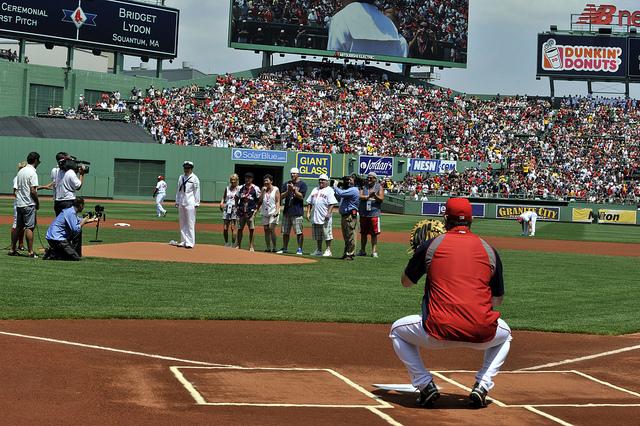What game are they playing?
Write a very short answer. Baseball. What do you call the man behind the catcher?
Be succinct. Umpire. Are there any empty seats?
Answer briefly. No. What company is advertised able Dunkin donuts?
Be succinct. New balance. Is the game starting?
Short answer required. Yes. Are the spectators cheering?
Write a very short answer. Yes. What color is the catcher's jersey?
Give a very brief answer. Red. Is this a practice or a game?
Concise answer only. Game. Which advertisement begins with the letter M?
Short answer required. None. Are the stands packed?
Be succinct. Yes. 